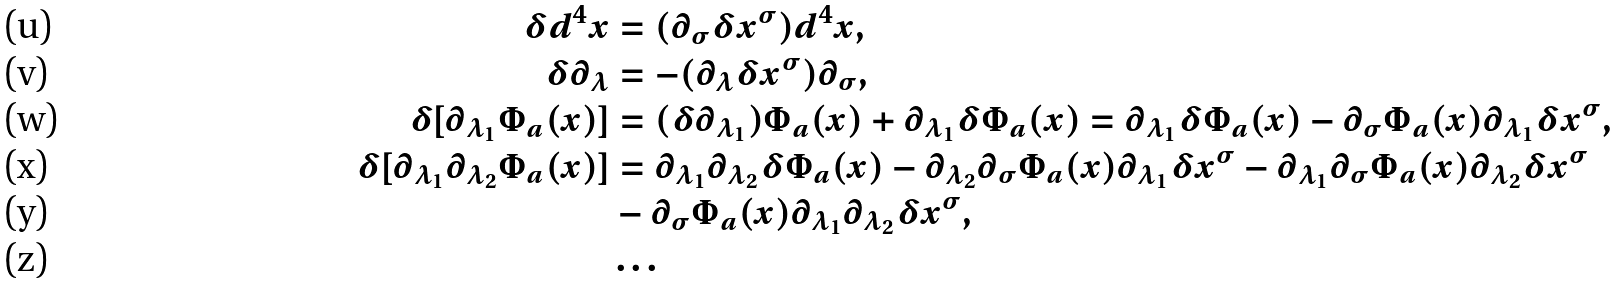Convert formula to latex. <formula><loc_0><loc_0><loc_500><loc_500>\delta d ^ { 4 } x & = ( \partial _ { \sigma } \delta x ^ { \sigma } ) d ^ { 4 } x , \\ \delta \partial _ { \lambda } & = - ( \partial _ { \lambda } \delta x ^ { \sigma } ) \partial _ { \sigma } , \\ \delta [ \partial _ { \lambda _ { 1 } } \Phi _ { a } ( x ) ] & = ( \delta \partial _ { \lambda _ { 1 } } ) \Phi _ { a } ( x ) + \partial _ { \lambda _ { 1 } } \delta \Phi _ { a } ( x ) = \partial _ { \lambda _ { 1 } } \delta \Phi _ { a } ( x ) - \partial _ { \sigma } \Phi _ { a } ( x ) \partial _ { \lambda _ { 1 } } \delta x ^ { \sigma } , \\ \delta [ \partial _ { \lambda _ { 1 } } \partial _ { \lambda _ { 2 } } \Phi _ { a } ( x ) ] & = \partial _ { \lambda _ { 1 } } \partial _ { \lambda _ { 2 } } \delta \Phi _ { a } ( x ) - \partial _ { \lambda _ { 2 } } \partial _ { \sigma } \Phi _ { a } ( x ) \partial _ { \lambda _ { 1 } } \delta x ^ { \sigma } - \partial _ { \lambda _ { 1 } } \partial _ { \sigma } \Phi _ { a } ( x ) \partial _ { \lambda _ { 2 } } \delta x ^ { \sigma } \\ & - \partial _ { \sigma } \Phi _ { a } ( x ) \partial _ { \lambda _ { 1 } } \partial _ { \lambda _ { 2 } } \delta x ^ { \sigma } , \\ & \dots</formula> 